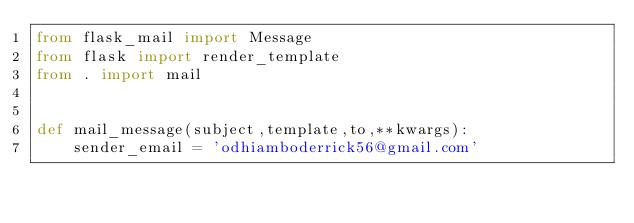<code> <loc_0><loc_0><loc_500><loc_500><_Python_>from flask_mail import Message
from flask import render_template
from . import mail


def mail_message(subject,template,to,**kwargs):
    sender_email = 'odhiamboderrick56@gmail.com'
</code> 